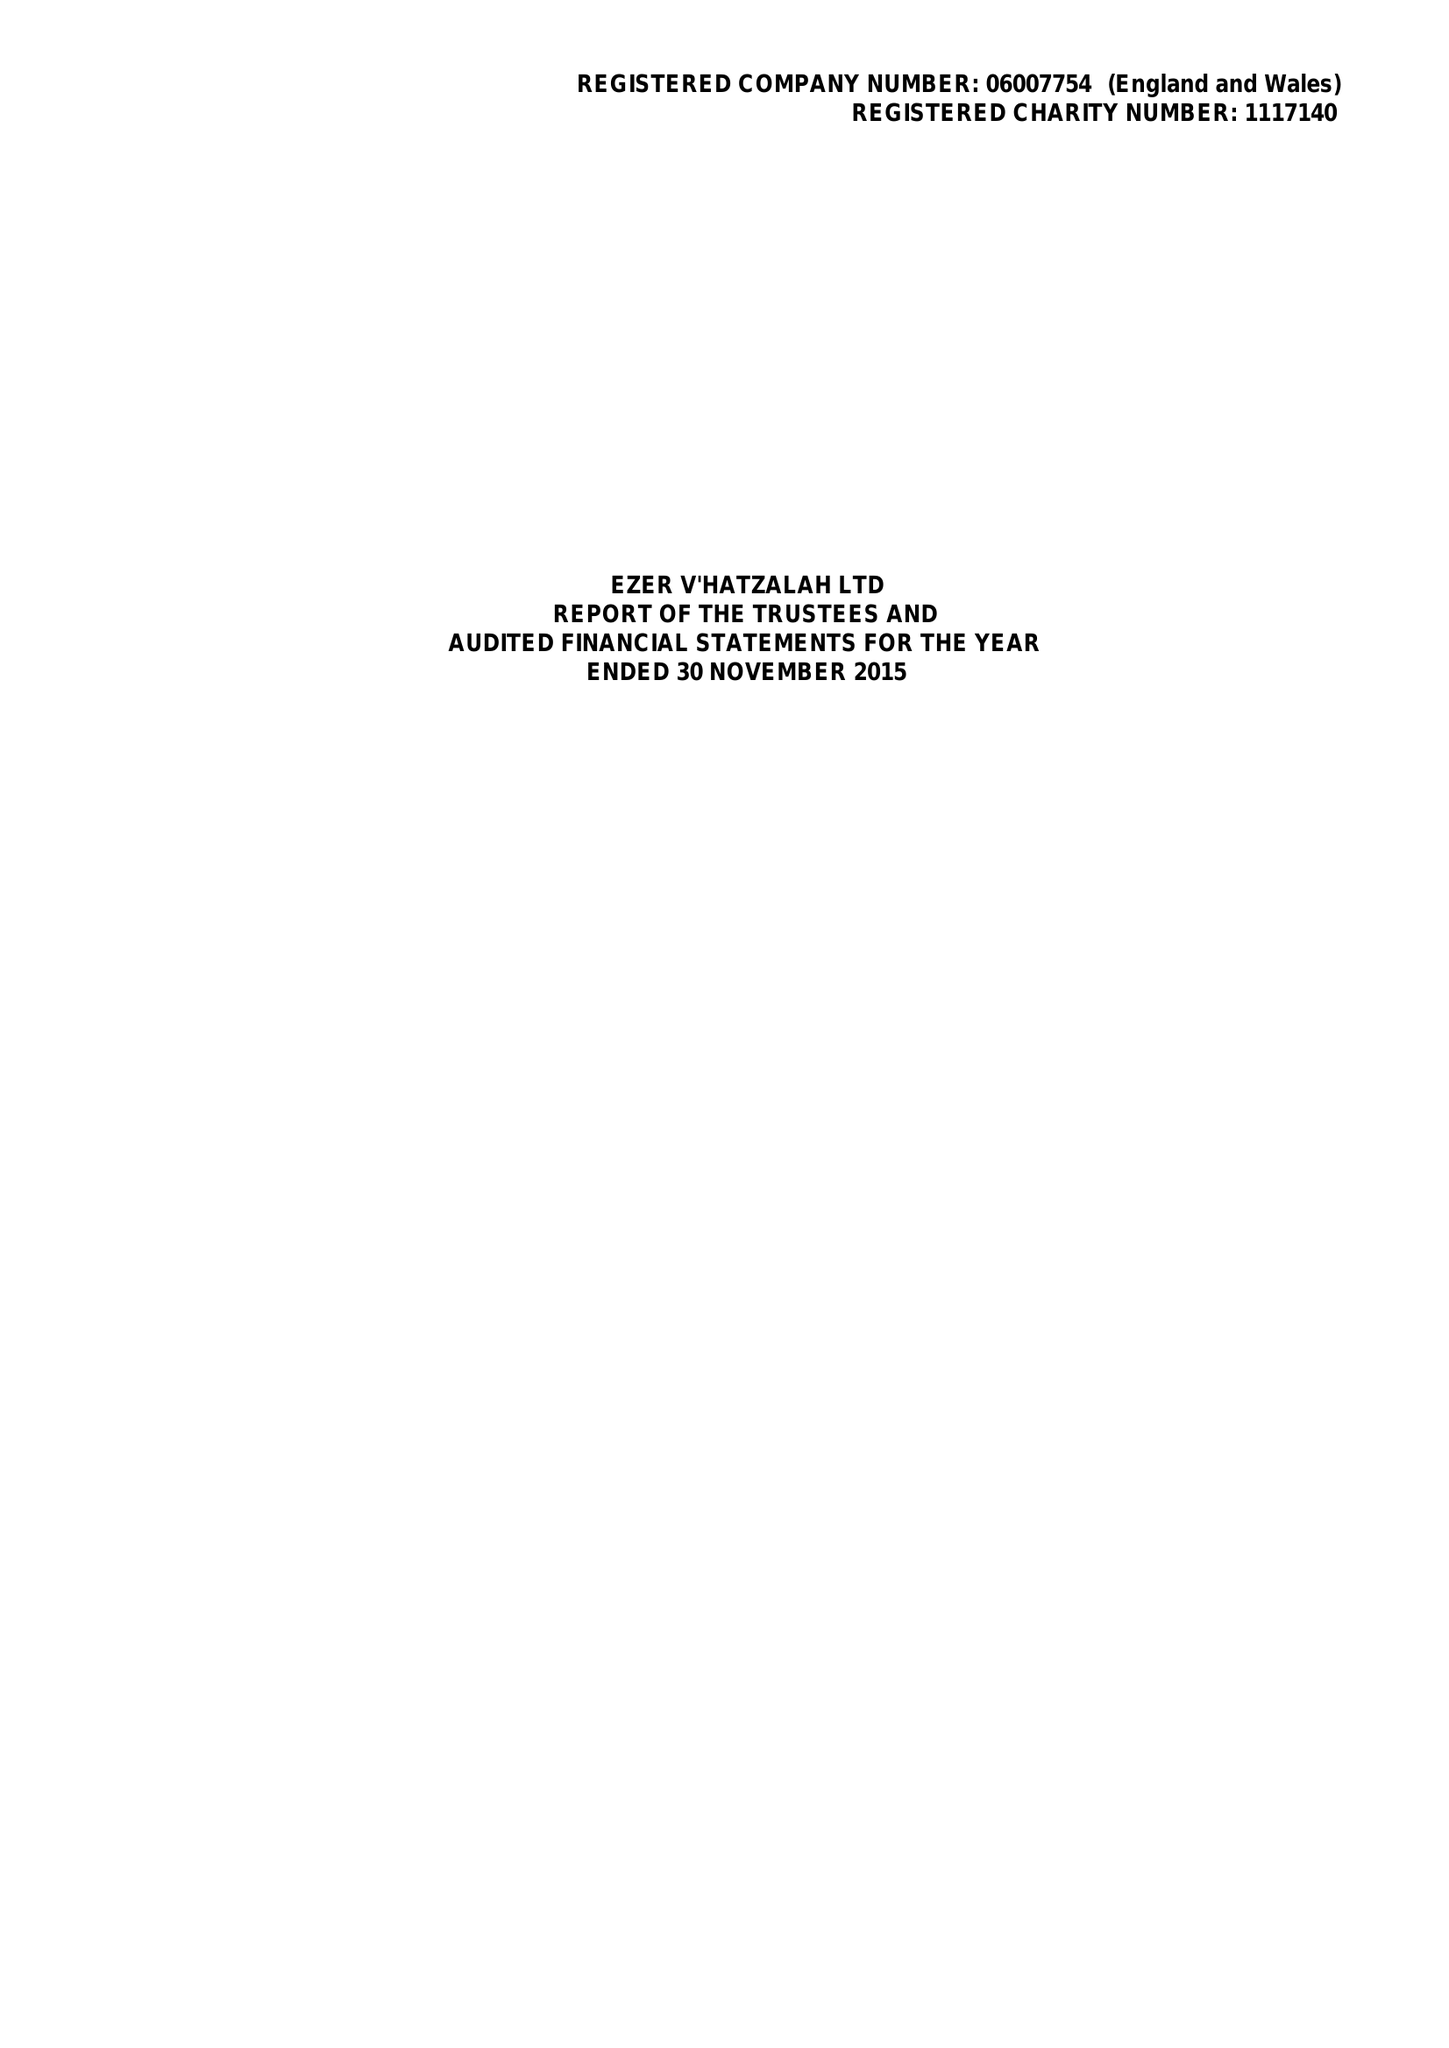What is the value for the report_date?
Answer the question using a single word or phrase. 2015-11-30 